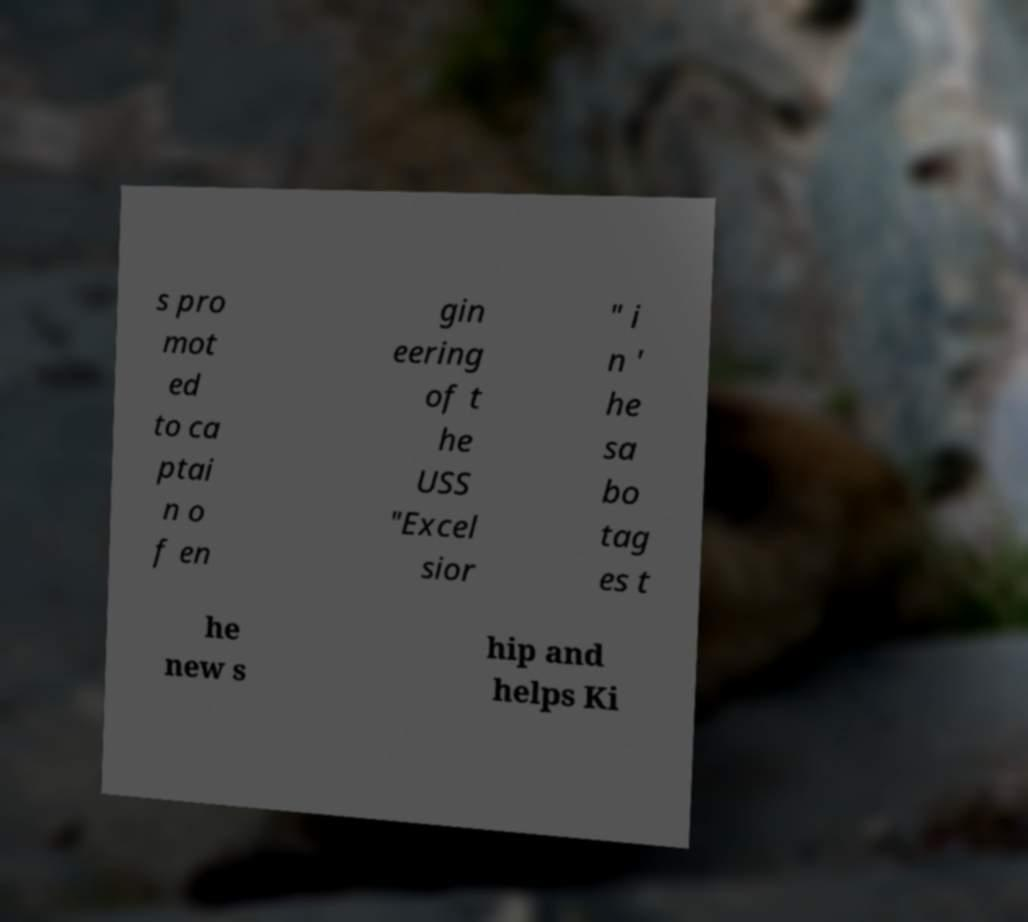Could you assist in decoding the text presented in this image and type it out clearly? s pro mot ed to ca ptai n o f en gin eering of t he USS "Excel sior " i n ' he sa bo tag es t he new s hip and helps Ki 